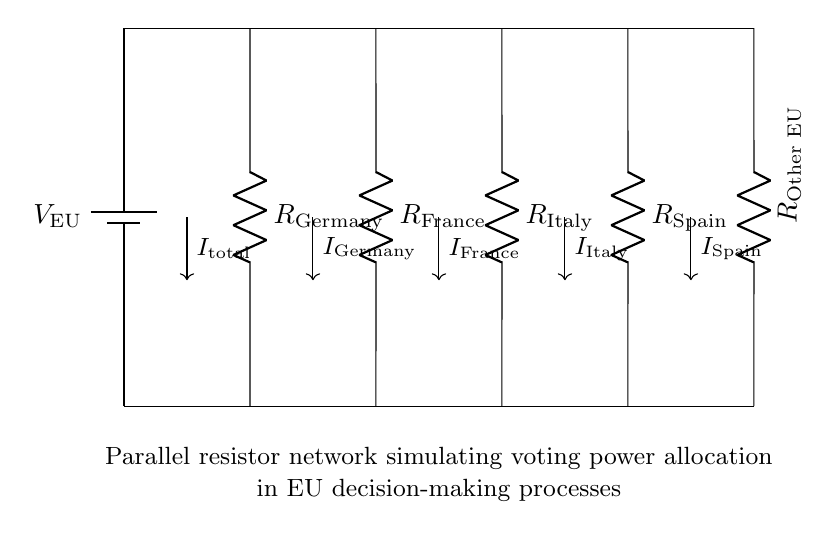What type of circuit is represented? The circuit represents a parallel resistor network, as all resistors are connected across the same voltage source with a common input and output.
Answer: Parallel resistor network How many resistors are in the circuit? There are five resistors depicted in the circuit, labeled as Germany, France, Italy, Spain, and Other EU.
Answer: Five What is the total current flowing through the network? The total current is denoted as I_total, and it represents the sum of the currents flowing through each parallel path according to Kirchhoff's current law.
Answer: I_total Which country has the highest voting power represented by the largest resistor? In a current divider, a larger resistor corresponds to a lower current flow, indicating less power. Therefore, Other EU likely implies a larger resistor, showing higher voting power.
Answer: Other EU What relationship exists between voltage and current in this circuit? In a parallel resistor network, the voltage across each resistor is the same and equal to the source voltage, but the currents through each resistor are inversely proportional to their resistances.
Answer: Same voltage If Germany's resistor value is increased, what happens to its current? If Germany's resistor value increases, according to Ohm's Law, the current flowing through that resistor decreases because current is inversely related to resistance in parallel circuits.
Answer: Current decreases 